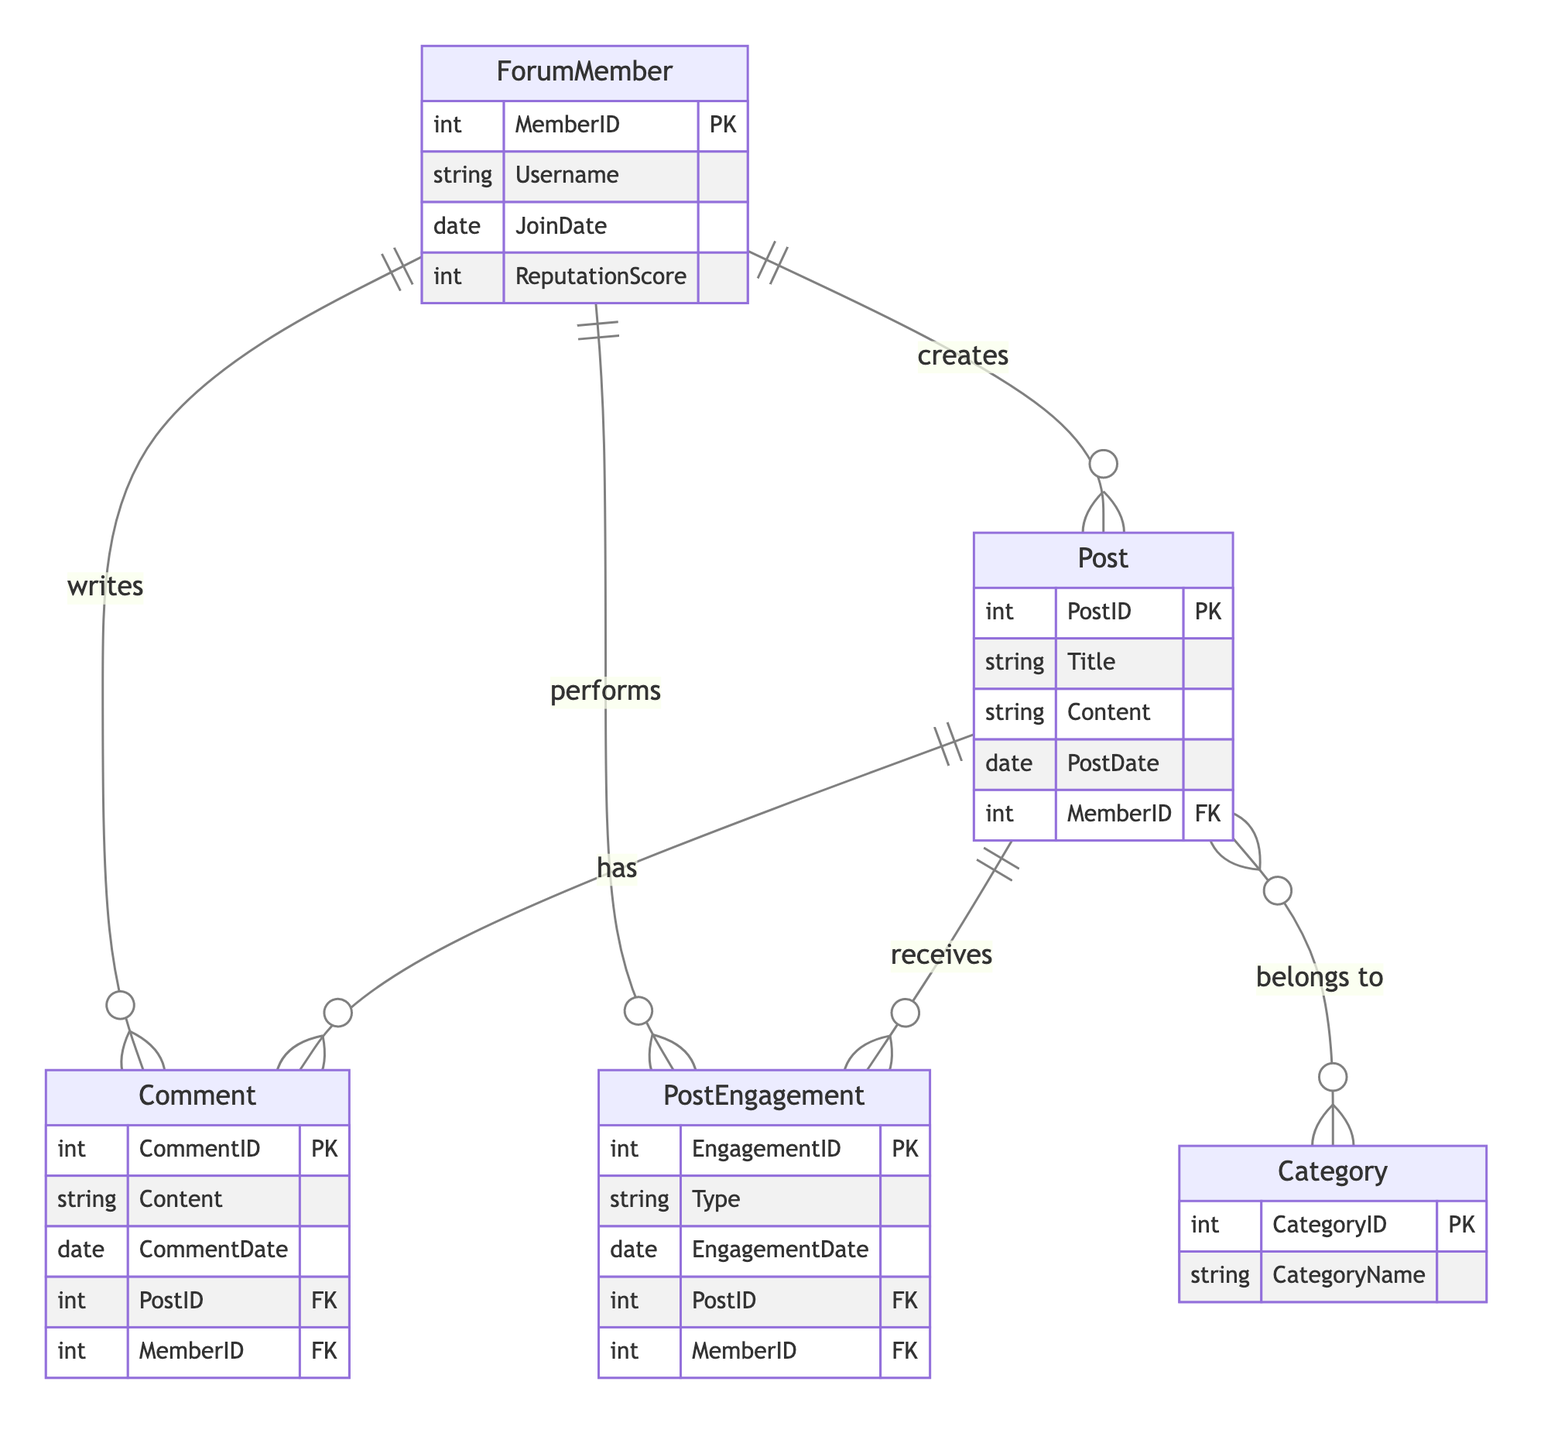What is the primary key of the ForumMember entity? The primary key is a unique identifier for each entity. In the ForumMember entity, the primary key is indicated as MemberID.
Answer: MemberID How many attributes does the Post entity have? Attributes are the defining properties of an entity. The Post entity lists five attributes: PostID, Title, Content, PostDate, and MemberID.
Answer: Five Which entity can write Comments? The diagram shows that ForumMember has a one-to-many relationship with Comment, indicating that each forum member can write multiple comments.
Answer: ForumMember What type of relationship exists between Post and Comment? The relationship is one-to-many, which is indicated by the line connecting Post to Comment with a "has" label. This means one post can have many comments.
Answer: One-to-Many How many categories can a post belong to? The diagram indicates a many-to-many relationship between Post and Category, meaning that a post can belong to multiple categories.
Answer: Multiple What entity performs PostEngagement? The diagram shows that ForumMember performs PostEngagement based on the relationship illustrated. Each member can perform multiple engagements on posts.
Answer: ForumMember Which entity has the highest level of engagement? The diagram does not specify a maximum or highest level of engagement by quantity but indicates that members can engage multiple times with posts, potentially leading to varying engagement levels.
Answer: Not determined How many types of post engagements can exist? The PostEngagement entity has a Type attribute which can include multiple types, such as 'Like', 'Dislike', and 'Share'. Thus, it can have various engagement types.
Answer: Multiple types Which entity is directly related to the MemberID? The diagram shows that MemberID (as a foreign key) relates directly to Post, Comment, and PostEngagement, linking members to their posts and engagements.
Answer: Post, Comment, PostEngagement 